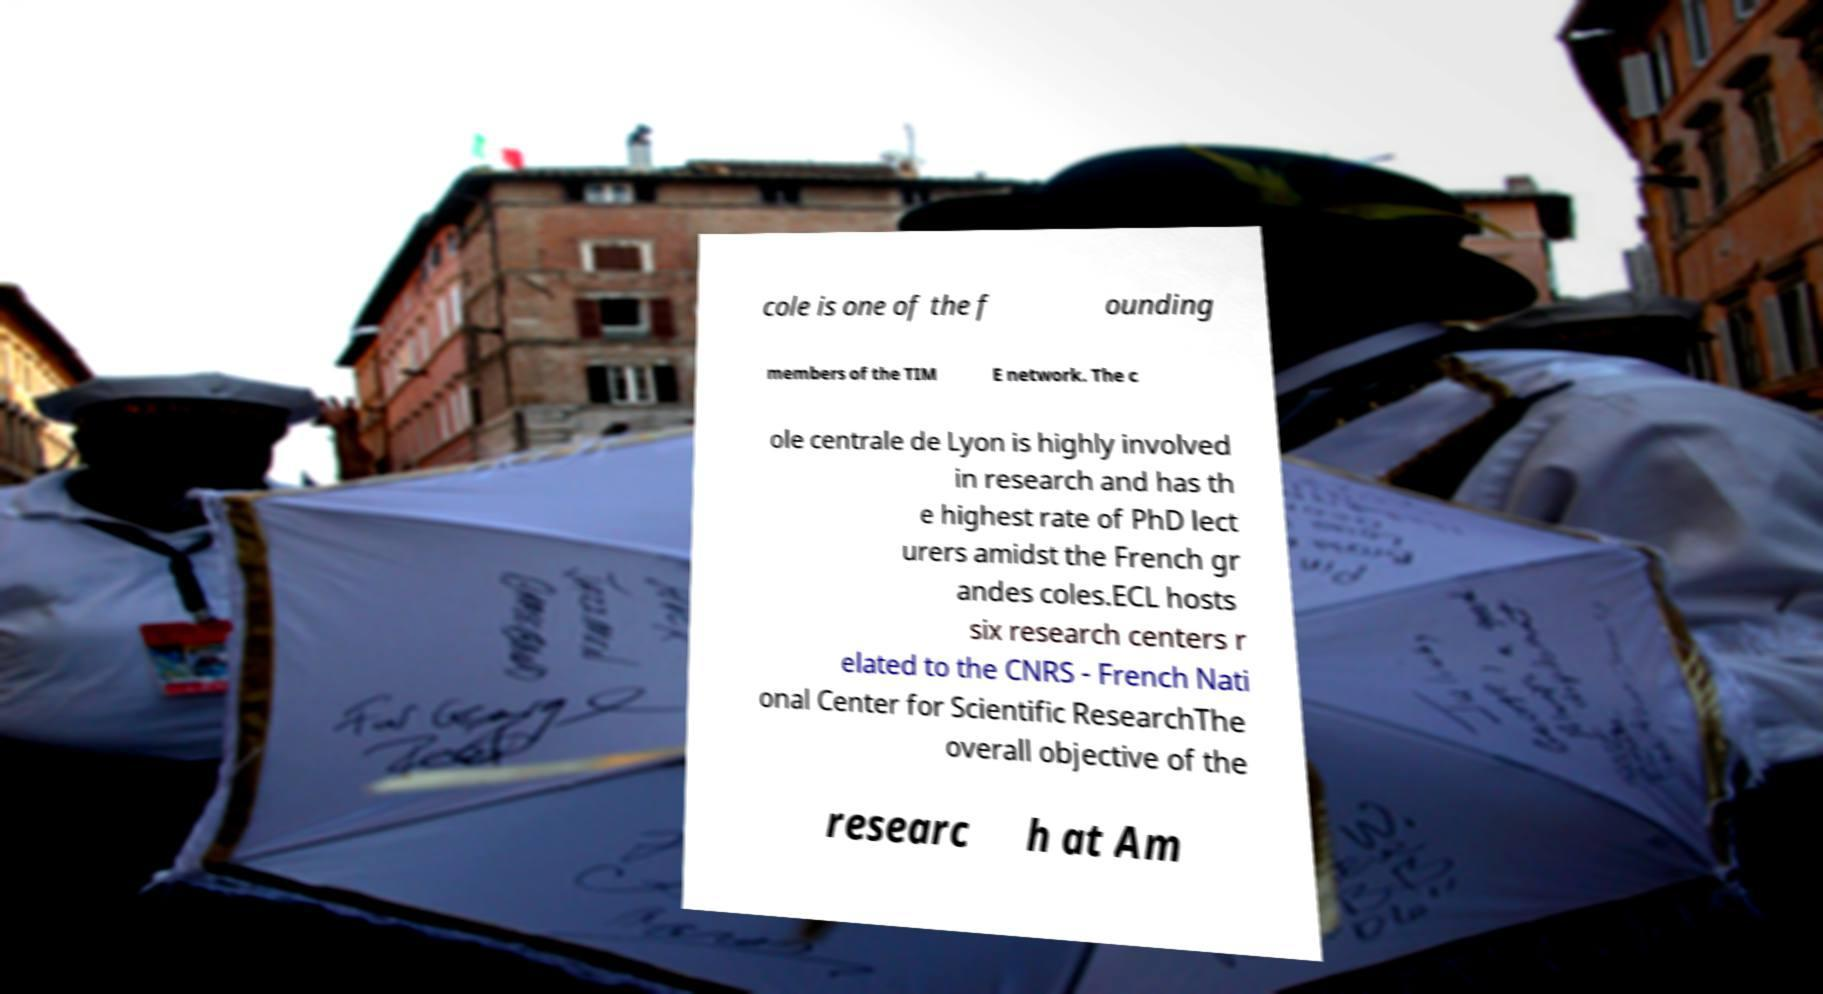Could you extract and type out the text from this image? cole is one of the f ounding members of the TIM E network. The c ole centrale de Lyon is highly involved in research and has th e highest rate of PhD lect urers amidst the French gr andes coles.ECL hosts six research centers r elated to the CNRS - French Nati onal Center for Scientific ResearchThe overall objective of the researc h at Am 